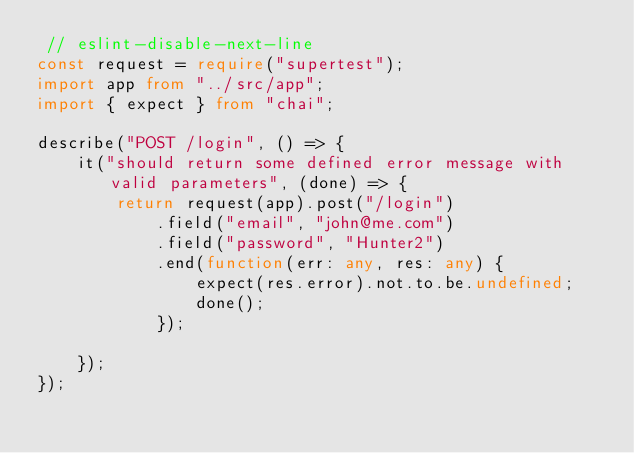Convert code to text. <code><loc_0><loc_0><loc_500><loc_500><_TypeScript_> // eslint-disable-next-line
const request = require("supertest");
import app from "../src/app";
import { expect } from "chai";

describe("POST /login", () => {
    it("should return some defined error message with valid parameters", (done) => {
        return request(app).post("/login")
            .field("email", "john@me.com")
            .field("password", "Hunter2")
            .end(function(err: any, res: any) {
                expect(res.error).not.to.be.undefined;
                done();
            });

    });
});
</code> 